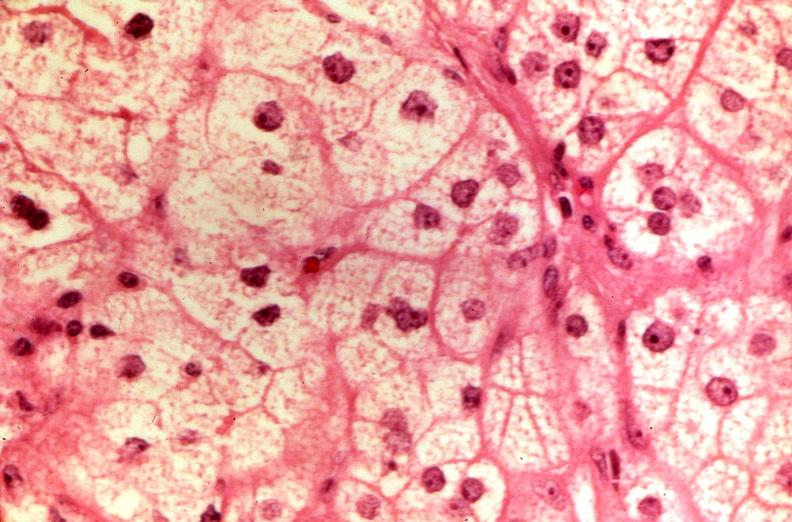does retroperitoneal leiomyosarcoma show pituitary, chromaphobe adenoma?
Answer the question using a single word or phrase. No 